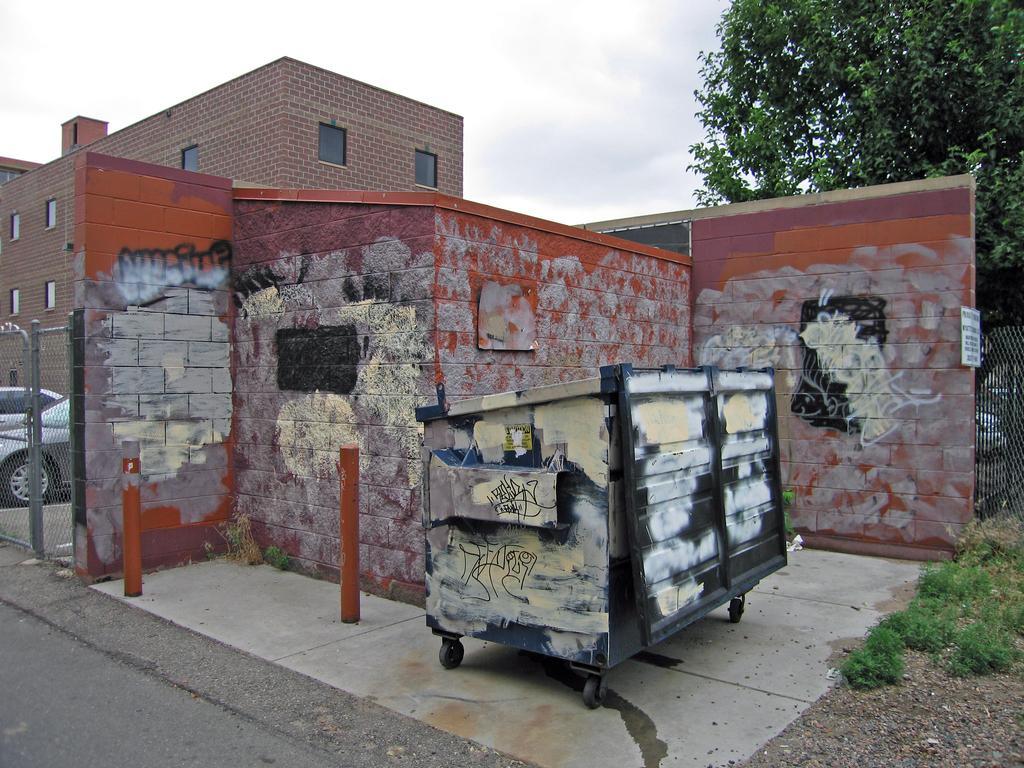In one or two sentences, can you explain what this image depicts? In this picture we can see a cart, vehicles and traffic poles on the ground and in the background we can see buildings, trees and the sky. 